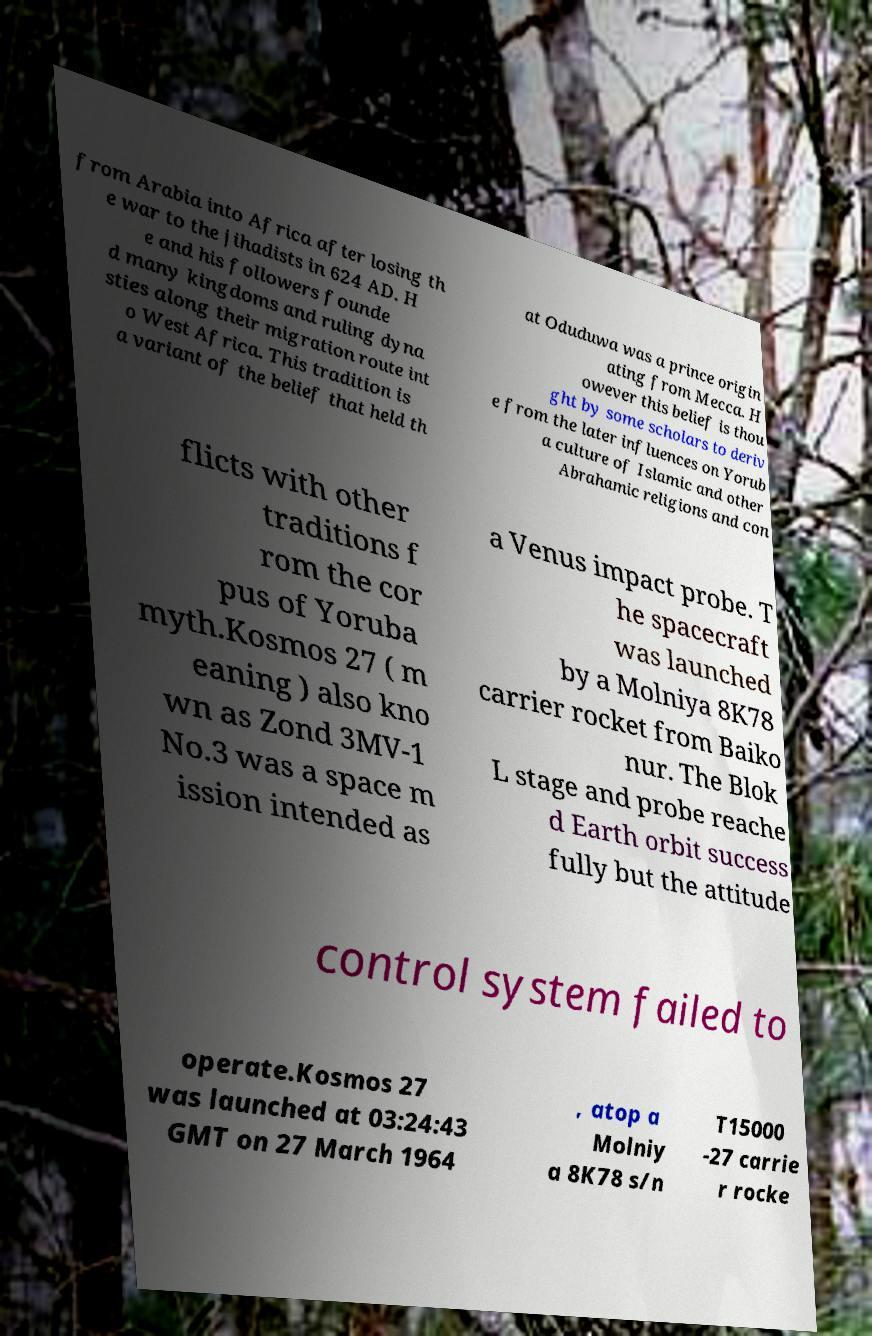Please read and relay the text visible in this image. What does it say? from Arabia into Africa after losing th e war to the jihadists in 624 AD. H e and his followers founde d many kingdoms and ruling dyna sties along their migration route int o West Africa. This tradition is a variant of the belief that held th at Oduduwa was a prince origin ating from Mecca. H owever this belief is thou ght by some scholars to deriv e from the later influences on Yorub a culture of Islamic and other Abrahamic religions and con flicts with other traditions f rom the cor pus of Yoruba myth.Kosmos 27 ( m eaning ) also kno wn as Zond 3MV-1 No.3 was a space m ission intended as a Venus impact probe. T he spacecraft was launched by a Molniya 8K78 carrier rocket from Baiko nur. The Blok L stage and probe reache d Earth orbit success fully but the attitude control system failed to operate.Kosmos 27 was launched at 03:24:43 GMT on 27 March 1964 , atop a Molniy a 8K78 s/n T15000 -27 carrie r rocke 